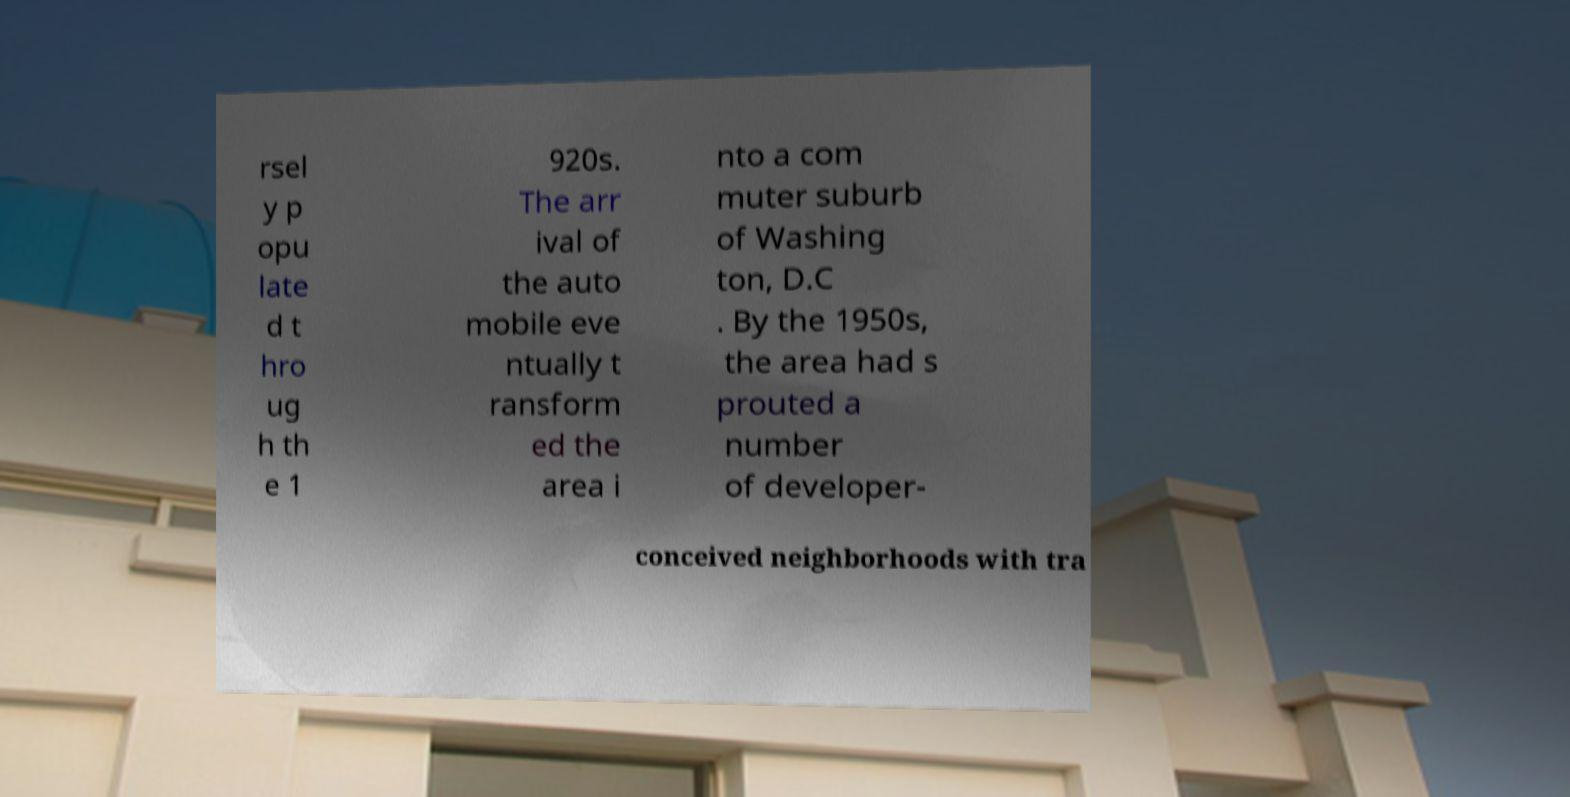Can you read and provide the text displayed in the image?This photo seems to have some interesting text. Can you extract and type it out for me? rsel y p opu late d t hro ug h th e 1 920s. The arr ival of the auto mobile eve ntually t ransform ed the area i nto a com muter suburb of Washing ton, D.C . By the 1950s, the area had s prouted a number of developer- conceived neighborhoods with tra 